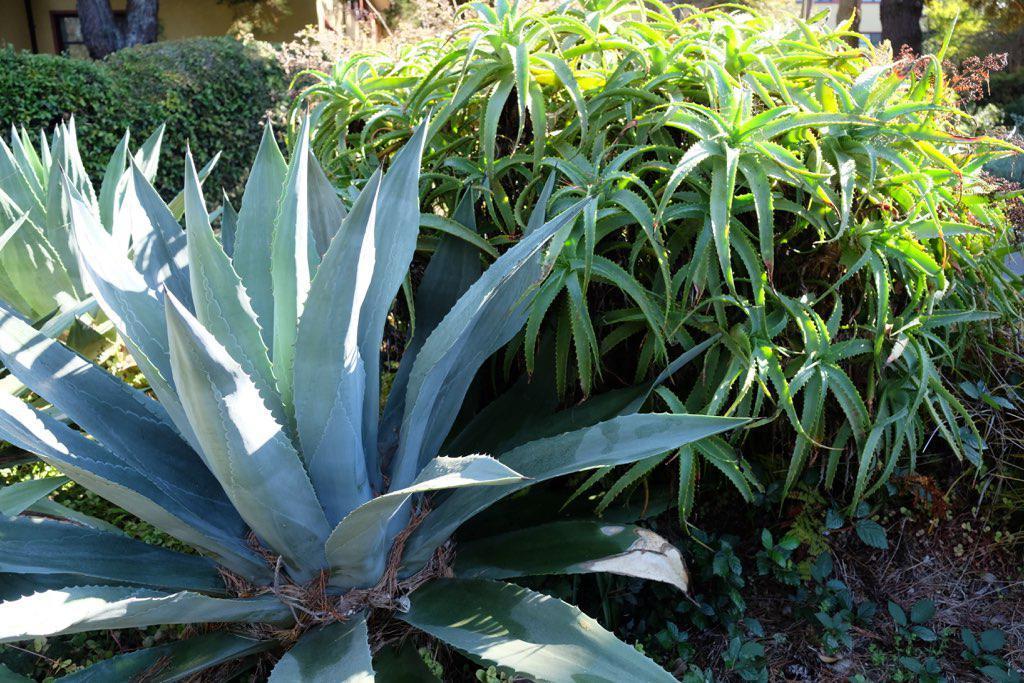How would you summarize this image in a sentence or two? In this image there is a Agave tequilana plant on the left side, Beside it there is another small plant. In the background there is a tree. On the ground there are small plants and stones. 